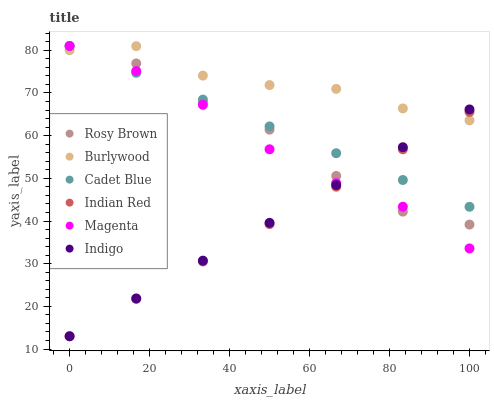Does Indian Red have the minimum area under the curve?
Answer yes or no. Yes. Does Burlywood have the maximum area under the curve?
Answer yes or no. Yes. Does Indigo have the minimum area under the curve?
Answer yes or no. No. Does Indigo have the maximum area under the curve?
Answer yes or no. No. Is Indian Red the smoothest?
Answer yes or no. Yes. Is Rosy Brown the roughest?
Answer yes or no. Yes. Is Indigo the smoothest?
Answer yes or no. No. Is Indigo the roughest?
Answer yes or no. No. Does Indigo have the lowest value?
Answer yes or no. Yes. Does Burlywood have the lowest value?
Answer yes or no. No. Does Magenta have the highest value?
Answer yes or no. Yes. Does Indigo have the highest value?
Answer yes or no. No. Does Rosy Brown intersect Magenta?
Answer yes or no. Yes. Is Rosy Brown less than Magenta?
Answer yes or no. No. Is Rosy Brown greater than Magenta?
Answer yes or no. No. 